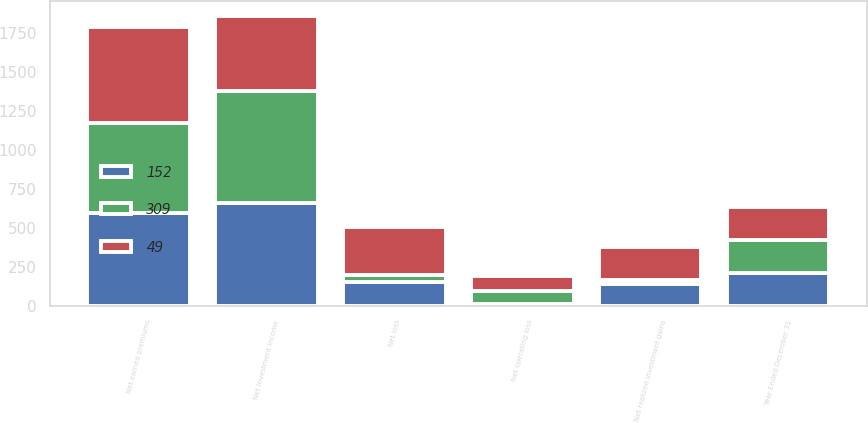<chart> <loc_0><loc_0><loc_500><loc_500><stacked_bar_chart><ecel><fcel>Year Ended December 31<fcel>Net earned premiums<fcel>Net investment income<fcel>Net operating loss<fcel>Net realized investment gains<fcel>Net loss<nl><fcel>309<fcel>212<fcel>582<fcel>715<fcel>79<fcel>30<fcel>49<nl><fcel>152<fcel>212<fcel>595<fcel>664<fcel>14<fcel>138<fcel>152<nl><fcel>49<fcel>212<fcel>612<fcel>484<fcel>97<fcel>212<fcel>309<nl></chart> 